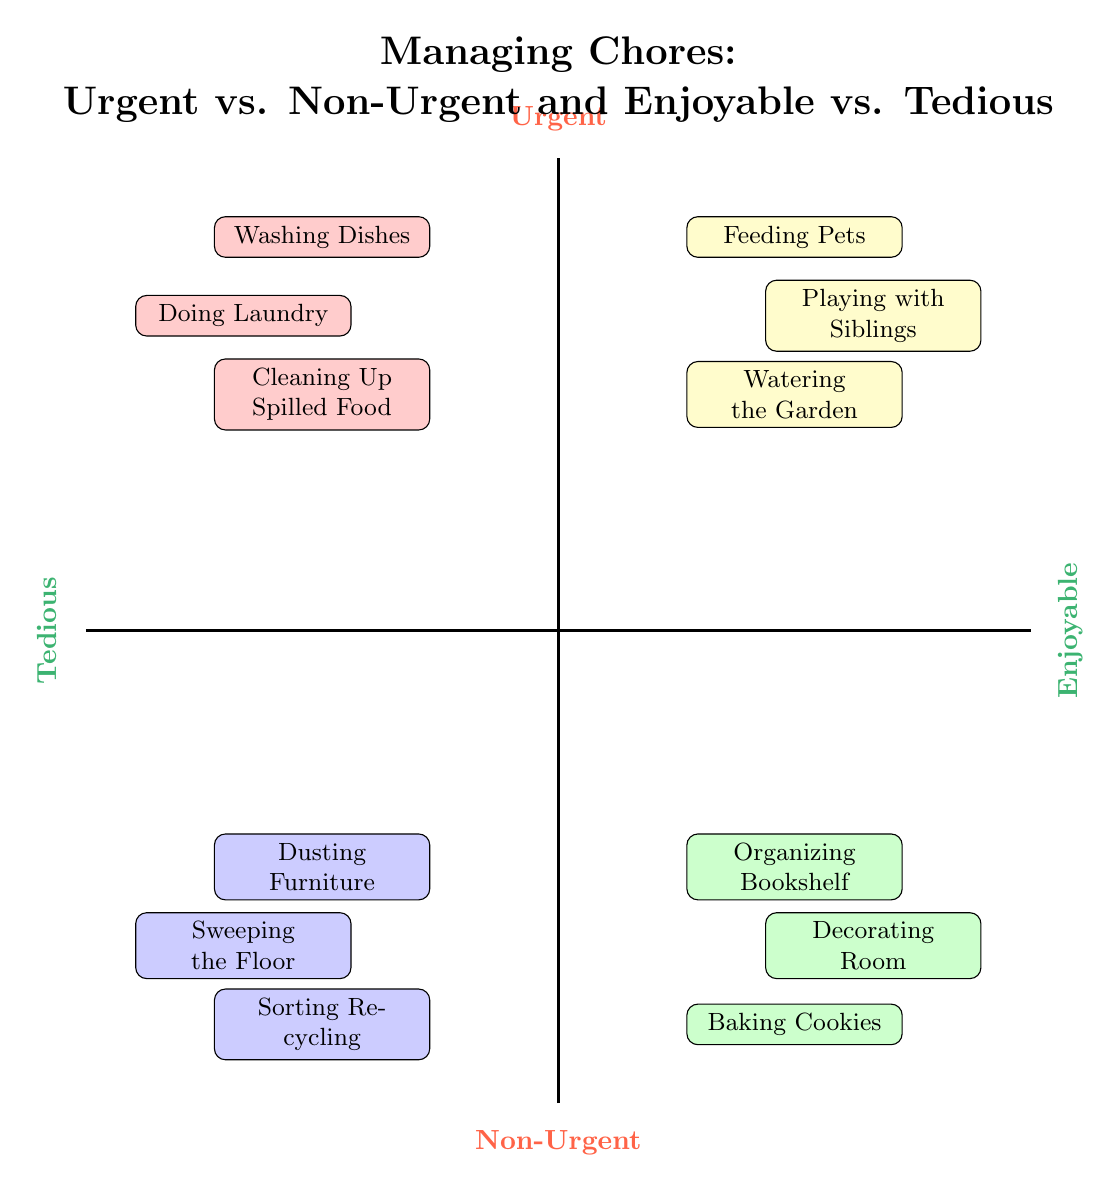What tasks are in the Urgent-Enjoyable quadrant? The Urgent-Enjoyable quadrant contains three tasks: Watering the Garden, Playing with Siblings, and Feeding Pets. These tasks can be found in the upper right section of the diagram.
Answer: Watering the Garden, Playing with Siblings, Feeding Pets How many tasks are categorized as Non-Urgent-Tedious? In the Non-Urgent-Tedious quadrant, there are three tasks listed: Dusting Furniture, Sweeping the Floor, and Sorting Recycling. Therefore, the number of tasks in this quadrant is three.
Answer: 3 Which task is both Urgent and Tedious? The tasks in the Urgent-Tedious quadrant include Cleaning Up Spilled Food, Doing Laundry, and Washing Dishes. Any of these can be selected as an answer since they all match the criteria.
Answer: Cleaning Up Spilled Food How does the number of Urgent-Enjoyable tasks compare to Non-Urgent-Enjoyable tasks? There are three tasks in both the Urgent-Enjoyable quadrant and the Non-Urgent-Enjoyable quadrant. Therefore, they have the same number of tasks, which is three for each.
Answer: Same number Which quadrant contains only enjoyable tasks? The quadrants containing enjoyable tasks include Urgent-Enjoyable and Non-Urgent-Enjoyable. However, the question asks for the quadrant containing only enjoyable tasks, which is the Non-Urgent-Enjoyable quadrant.
Answer: Non-Urgent-Enjoyable List one task that is classified as Non-Urgent and Tedious. In the Non-Urgent-Tedious quadrant, the tasks include Dusting Furniture, Sweeping the Floor, and Sorting Recycling. Any one of these can be selected as an answer, such as Dusting Furniture.
Answer: Dusting Furniture 